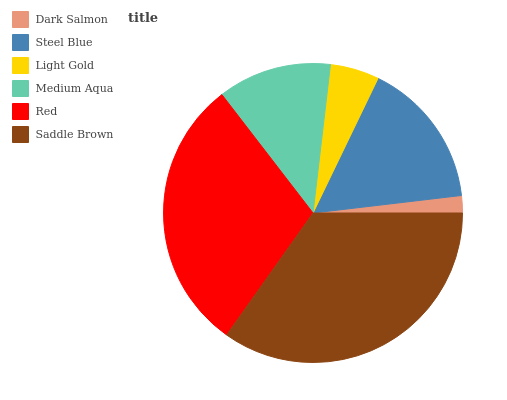Is Dark Salmon the minimum?
Answer yes or no. Yes. Is Saddle Brown the maximum?
Answer yes or no. Yes. Is Steel Blue the minimum?
Answer yes or no. No. Is Steel Blue the maximum?
Answer yes or no. No. Is Steel Blue greater than Dark Salmon?
Answer yes or no. Yes. Is Dark Salmon less than Steel Blue?
Answer yes or no. Yes. Is Dark Salmon greater than Steel Blue?
Answer yes or no. No. Is Steel Blue less than Dark Salmon?
Answer yes or no. No. Is Steel Blue the high median?
Answer yes or no. Yes. Is Medium Aqua the low median?
Answer yes or no. Yes. Is Dark Salmon the high median?
Answer yes or no. No. Is Dark Salmon the low median?
Answer yes or no. No. 